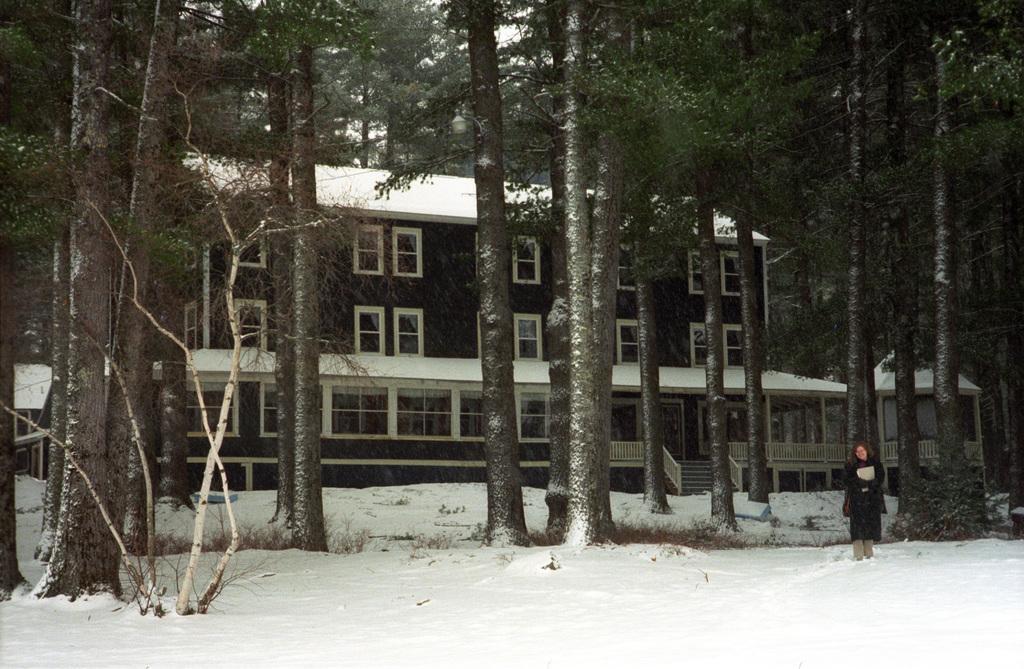Please provide a concise description of this image. In this image, we can see trees, snow and plants. Background we can see building, shed, walls, windows, railings, poles and stairs. On the right side of the image, we can see a person is standing on the snow. 